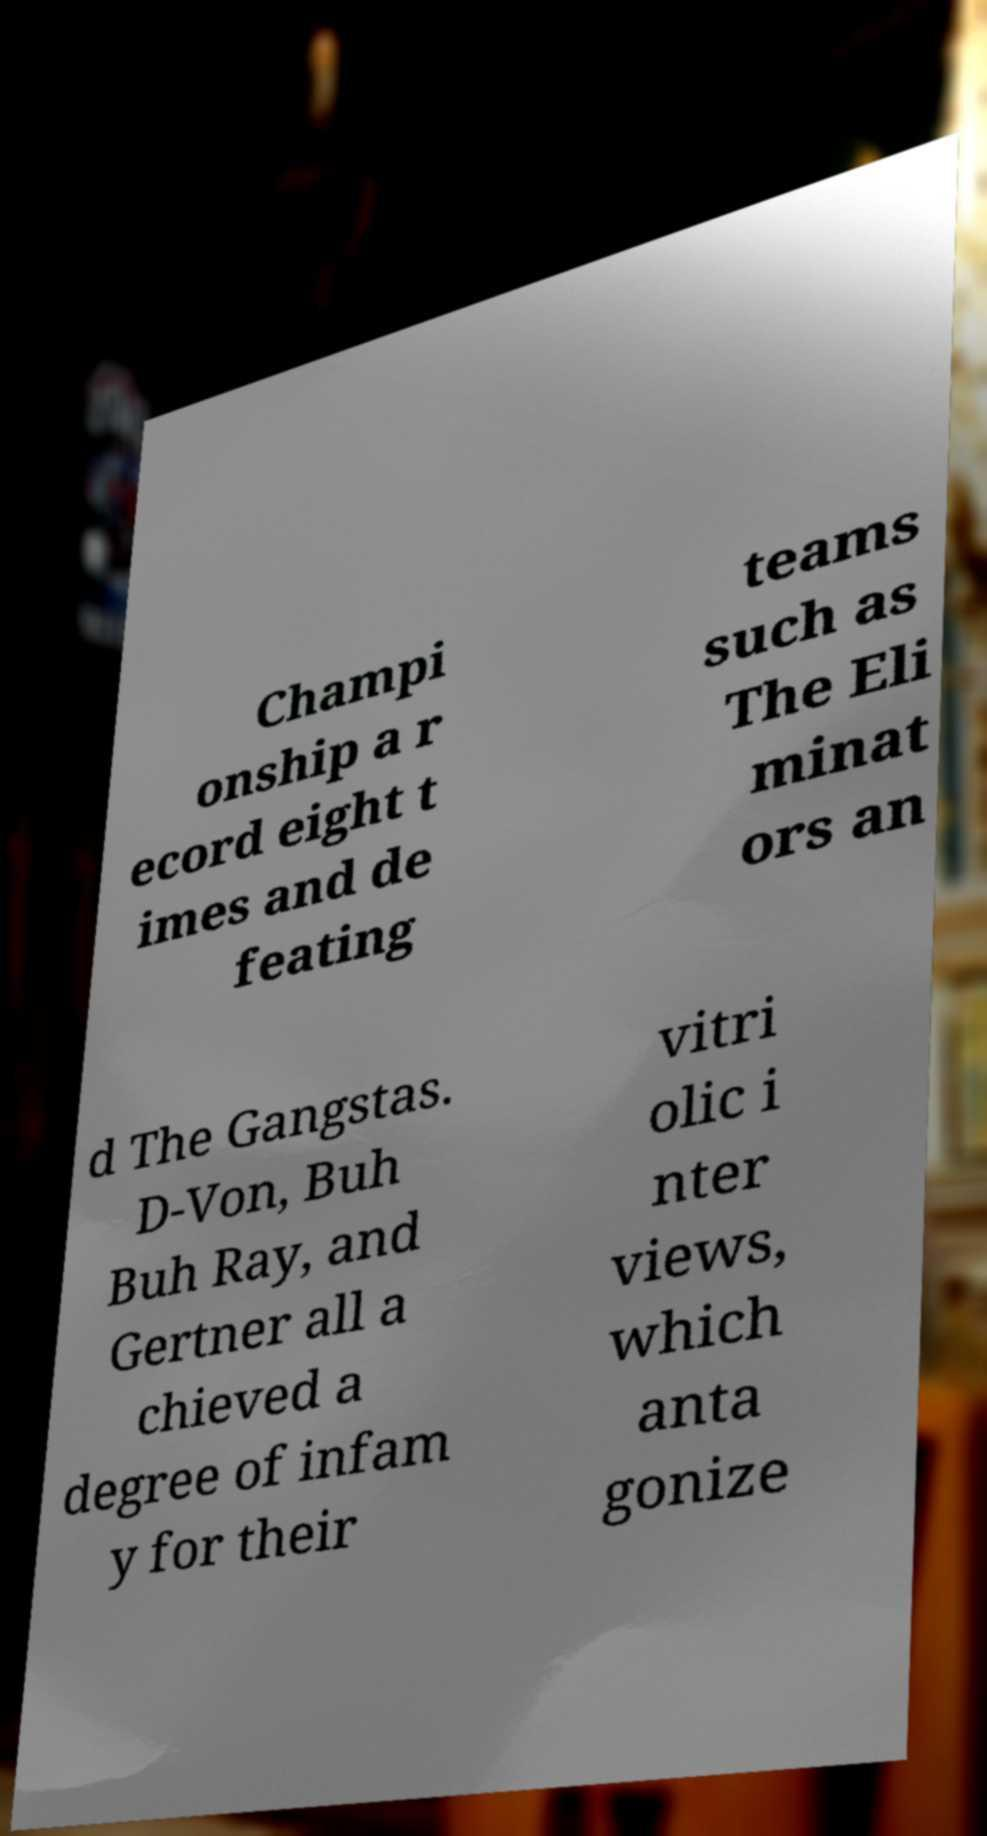What messages or text are displayed in this image? I need them in a readable, typed format. Champi onship a r ecord eight t imes and de feating teams such as The Eli minat ors an d The Gangstas. D-Von, Buh Buh Ray, and Gertner all a chieved a degree of infam y for their vitri olic i nter views, which anta gonize 